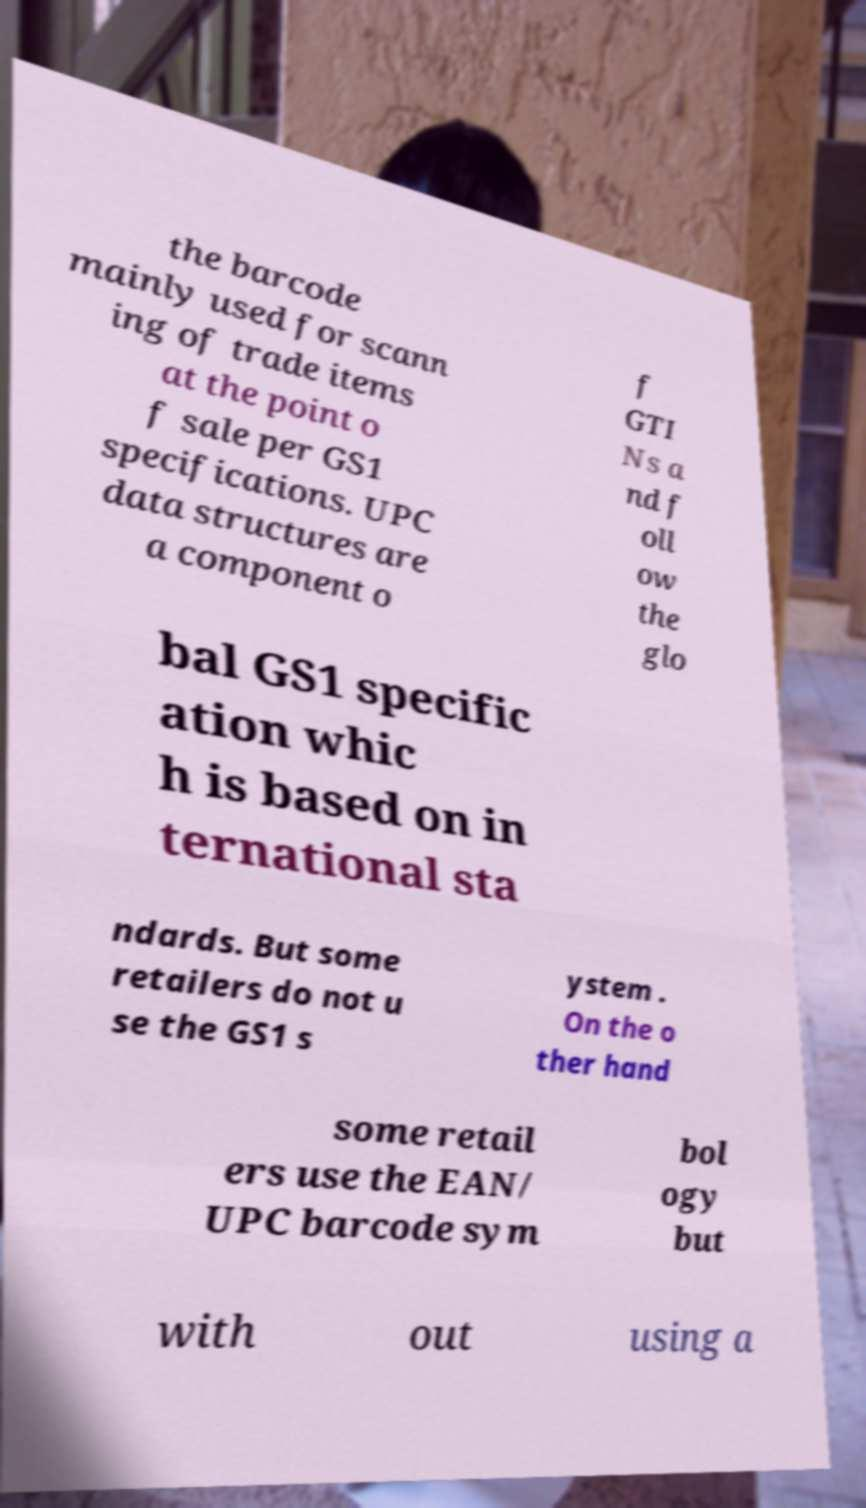I need the written content from this picture converted into text. Can you do that? the barcode mainly used for scann ing of trade items at the point o f sale per GS1 specifications. UPC data structures are a component o f GTI Ns a nd f oll ow the glo bal GS1 specific ation whic h is based on in ternational sta ndards. But some retailers do not u se the GS1 s ystem . On the o ther hand some retail ers use the EAN/ UPC barcode sym bol ogy but with out using a 